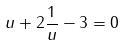<formula> <loc_0><loc_0><loc_500><loc_500>u + 2 \frac { 1 } { u } - 3 = 0</formula> 